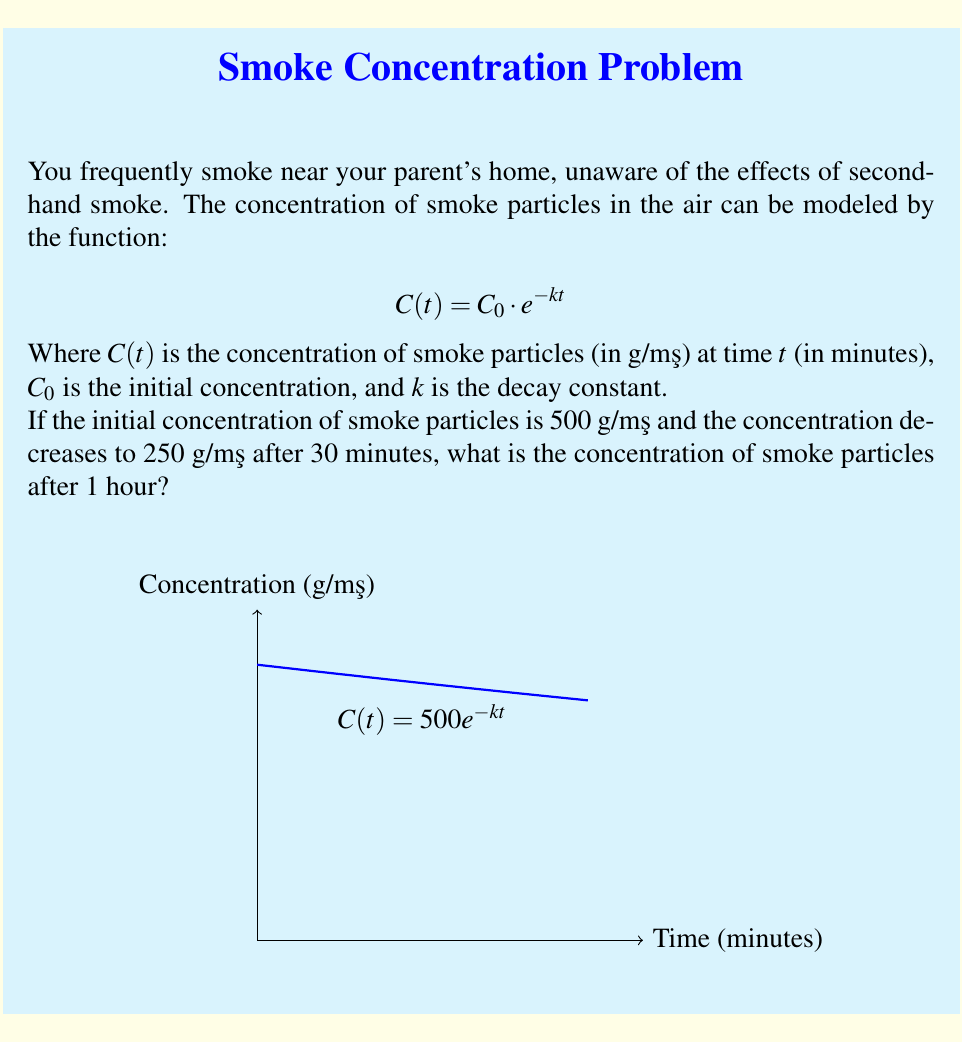Help me with this question. To solve this problem, we need to follow these steps:

1) First, let's determine the decay constant $k$ using the given information:
   $C(30) = 250 = 500 \cdot e^{-30k}$

2) Divide both sides by 500:
   $\frac{1}{2} = e^{-30k}$

3) Take the natural logarithm of both sides:
   $\ln(\frac{1}{2}) = -30k$

4) Solve for $k$:
   $k = -\frac{\ln(\frac{1}{2})}{30} \approx 0.0231$

5) Now that we have $k$, we can use the original function to find the concentration after 60 minutes:
   $C(60) = 500 \cdot e^{-0.0231 \cdot 60}$

6) Calculate:
   $C(60) = 500 \cdot e^{-1.386} \approx 125.00$ μg/m³

Therefore, after 1 hour (60 minutes), the concentration of smoke particles will be approximately 125.00 μg/m³.
Answer: 125.00 μg/m³ 